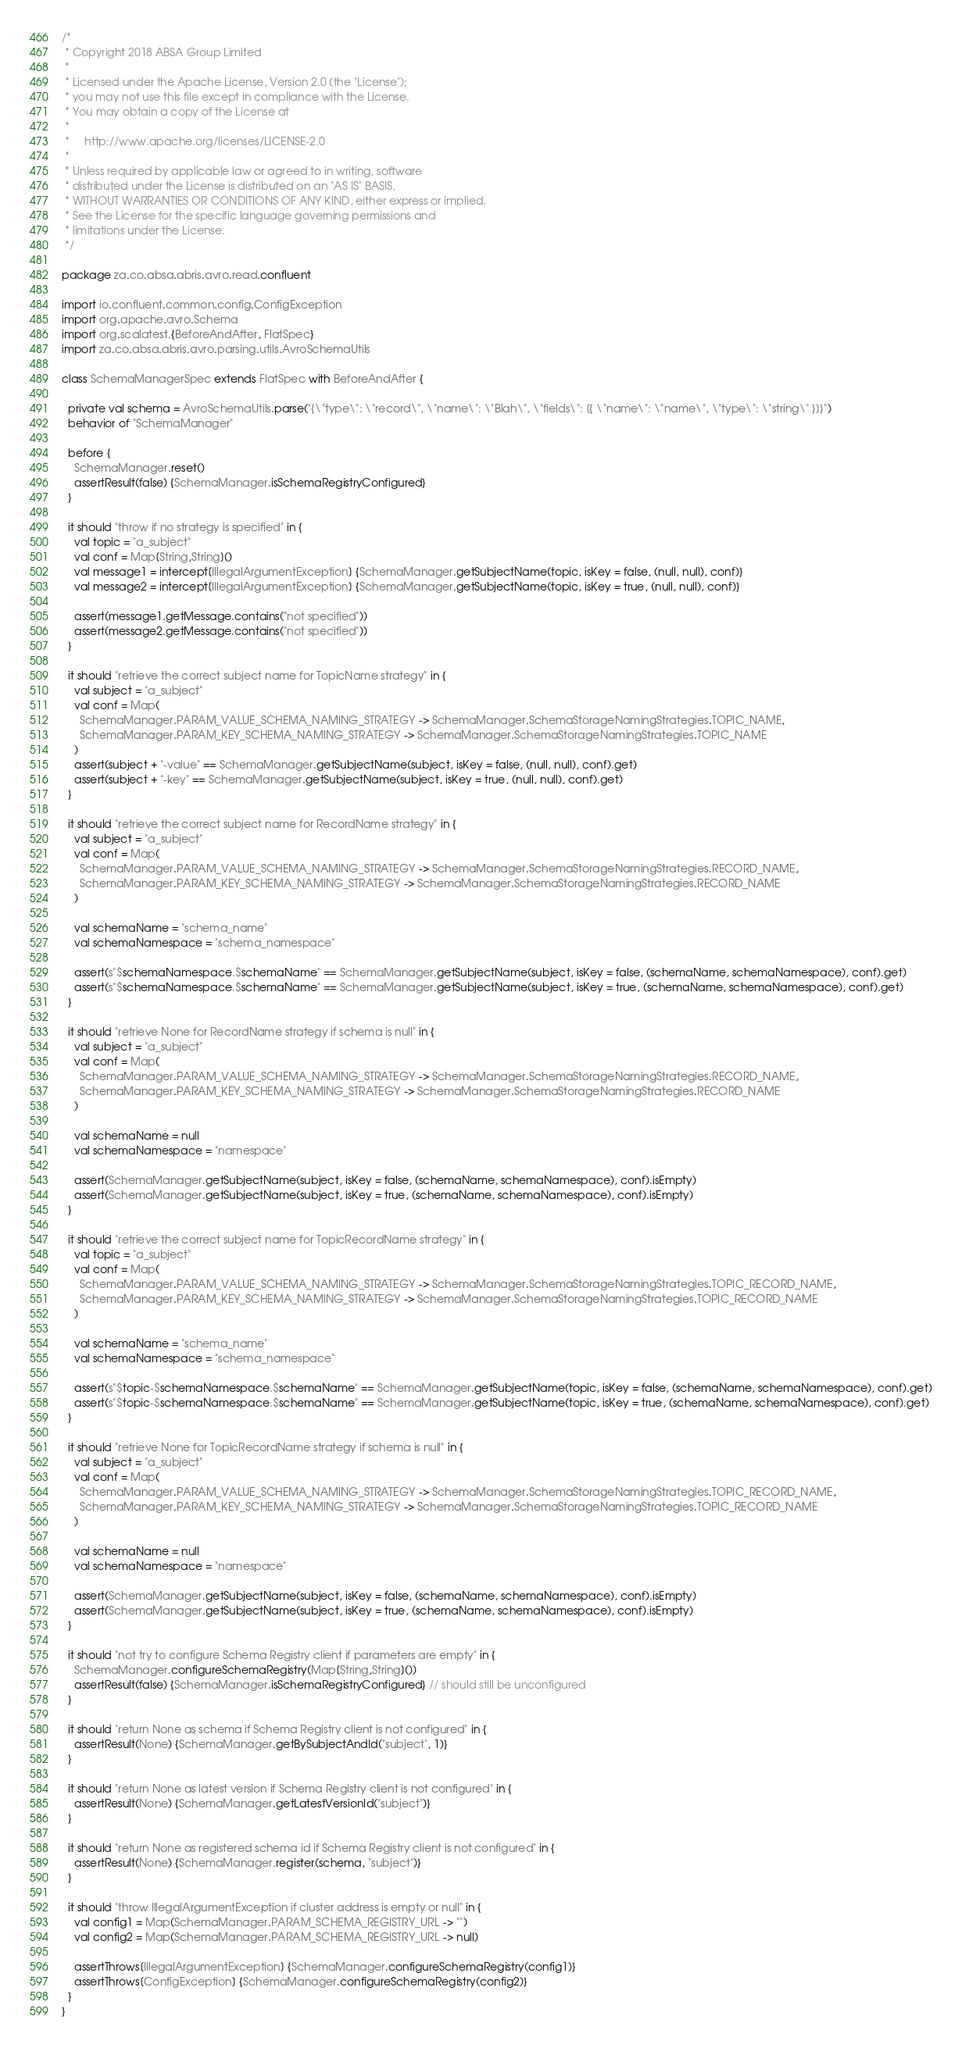Convert code to text. <code><loc_0><loc_0><loc_500><loc_500><_Scala_>/*
 * Copyright 2018 ABSA Group Limited
 *
 * Licensed under the Apache License, Version 2.0 (the "License");
 * you may not use this file except in compliance with the License.
 * You may obtain a copy of the License at
 *
 *     http://www.apache.org/licenses/LICENSE-2.0
 *
 * Unless required by applicable law or agreed to in writing, software
 * distributed under the License is distributed on an "AS IS" BASIS,
 * WITHOUT WARRANTIES OR CONDITIONS OF ANY KIND, either express or implied.
 * See the License for the specific language governing permissions and
 * limitations under the License.
 */

package za.co.absa.abris.avro.read.confluent

import io.confluent.common.config.ConfigException
import org.apache.avro.Schema
import org.scalatest.{BeforeAndAfter, FlatSpec}
import za.co.absa.abris.avro.parsing.utils.AvroSchemaUtils

class SchemaManagerSpec extends FlatSpec with BeforeAndAfter {

  private val schema = AvroSchemaUtils.parse("{\"type\": \"record\", \"name\": \"Blah\", \"fields\": [{ \"name\": \"name\", \"type\": \"string\" }]}")
  behavior of "SchemaManager"

  before {
    SchemaManager.reset()
    assertResult(false) {SchemaManager.isSchemaRegistryConfigured}
  }

  it should "throw if no strategy is specified" in {
    val topic = "a_subject"
    val conf = Map[String,String]()
    val message1 = intercept[IllegalArgumentException] {SchemaManager.getSubjectName(topic, isKey = false, (null, null), conf)}
    val message2 = intercept[IllegalArgumentException] {SchemaManager.getSubjectName(topic, isKey = true, (null, null), conf)}

    assert(message1.getMessage.contains("not specified"))
    assert(message2.getMessage.contains("not specified"))
  }

  it should "retrieve the correct subject name for TopicName strategy" in {
    val subject = "a_subject"
    val conf = Map(
      SchemaManager.PARAM_VALUE_SCHEMA_NAMING_STRATEGY -> SchemaManager.SchemaStorageNamingStrategies.TOPIC_NAME,
      SchemaManager.PARAM_KEY_SCHEMA_NAMING_STRATEGY -> SchemaManager.SchemaStorageNamingStrategies.TOPIC_NAME
    )
    assert(subject + "-value" == SchemaManager.getSubjectName(subject, isKey = false, (null, null), conf).get)
    assert(subject + "-key" == SchemaManager.getSubjectName(subject, isKey = true, (null, null), conf).get)
  }

  it should "retrieve the correct subject name for RecordName strategy" in {
    val subject = "a_subject"
    val conf = Map(
      SchemaManager.PARAM_VALUE_SCHEMA_NAMING_STRATEGY -> SchemaManager.SchemaStorageNamingStrategies.RECORD_NAME,
      SchemaManager.PARAM_KEY_SCHEMA_NAMING_STRATEGY -> SchemaManager.SchemaStorageNamingStrategies.RECORD_NAME
    )

    val schemaName = "schema_name"
    val schemaNamespace = "schema_namespace"

    assert(s"$schemaNamespace.$schemaName" == SchemaManager.getSubjectName(subject, isKey = false, (schemaName, schemaNamespace), conf).get)
    assert(s"$schemaNamespace.$schemaName" == SchemaManager.getSubjectName(subject, isKey = true, (schemaName, schemaNamespace), conf).get)
  }

  it should "retrieve None for RecordName strategy if schema is null" in {
    val subject = "a_subject"
    val conf = Map(
      SchemaManager.PARAM_VALUE_SCHEMA_NAMING_STRATEGY -> SchemaManager.SchemaStorageNamingStrategies.RECORD_NAME,
      SchemaManager.PARAM_KEY_SCHEMA_NAMING_STRATEGY -> SchemaManager.SchemaStorageNamingStrategies.RECORD_NAME
    )

    val schemaName = null
    val schemaNamespace = "namespace"

    assert(SchemaManager.getSubjectName(subject, isKey = false, (schemaName, schemaNamespace), conf).isEmpty)
    assert(SchemaManager.getSubjectName(subject, isKey = true, (schemaName, schemaNamespace), conf).isEmpty)
  }

  it should "retrieve the correct subject name for TopicRecordName strategy" in {
    val topic = "a_subject"
    val conf = Map(
      SchemaManager.PARAM_VALUE_SCHEMA_NAMING_STRATEGY -> SchemaManager.SchemaStorageNamingStrategies.TOPIC_RECORD_NAME,
      SchemaManager.PARAM_KEY_SCHEMA_NAMING_STRATEGY -> SchemaManager.SchemaStorageNamingStrategies.TOPIC_RECORD_NAME
    )

    val schemaName = "schema_name"
    val schemaNamespace = "schema_namespace"

    assert(s"$topic-$schemaNamespace.$schemaName" == SchemaManager.getSubjectName(topic, isKey = false, (schemaName, schemaNamespace), conf).get)
    assert(s"$topic-$schemaNamespace.$schemaName" == SchemaManager.getSubjectName(topic, isKey = true, (schemaName, schemaNamespace), conf).get)
  }

  it should "retrieve None for TopicRecordName strategy if schema is null" in {
    val subject = "a_subject"
    val conf = Map(
      SchemaManager.PARAM_VALUE_SCHEMA_NAMING_STRATEGY -> SchemaManager.SchemaStorageNamingStrategies.TOPIC_RECORD_NAME,
      SchemaManager.PARAM_KEY_SCHEMA_NAMING_STRATEGY -> SchemaManager.SchemaStorageNamingStrategies.TOPIC_RECORD_NAME
    )

    val schemaName = null
    val schemaNamespace = "namespace"

    assert(SchemaManager.getSubjectName(subject, isKey = false, (schemaName, schemaNamespace), conf).isEmpty)
    assert(SchemaManager.getSubjectName(subject, isKey = true, (schemaName, schemaNamespace), conf).isEmpty)
  }

  it should "not try to configure Schema Registry client if parameters are empty" in {
    SchemaManager.configureSchemaRegistry(Map[String,String]())
    assertResult(false) {SchemaManager.isSchemaRegistryConfigured} // should still be unconfigured
  }

  it should "return None as schema if Schema Registry client is not configured" in {
    assertResult(None) {SchemaManager.getBySubjectAndId("subject", 1)}
  }

  it should "return None as latest version if Schema Registry client is not configured" in {
    assertResult(None) {SchemaManager.getLatestVersionId("subject")}
  }

  it should "return None as registered schema id if Schema Registry client is not configured" in {
    assertResult(None) {SchemaManager.register(schema, "subject")}
  }

  it should "throw IllegalArgumentException if cluster address is empty or null" in {
    val config1 = Map(SchemaManager.PARAM_SCHEMA_REGISTRY_URL -> "")
    val config2 = Map(SchemaManager.PARAM_SCHEMA_REGISTRY_URL -> null)

    assertThrows[IllegalArgumentException] {SchemaManager.configureSchemaRegistry(config1)}
    assertThrows[ConfigException] {SchemaManager.configureSchemaRegistry(config2)}
  }
}
</code> 